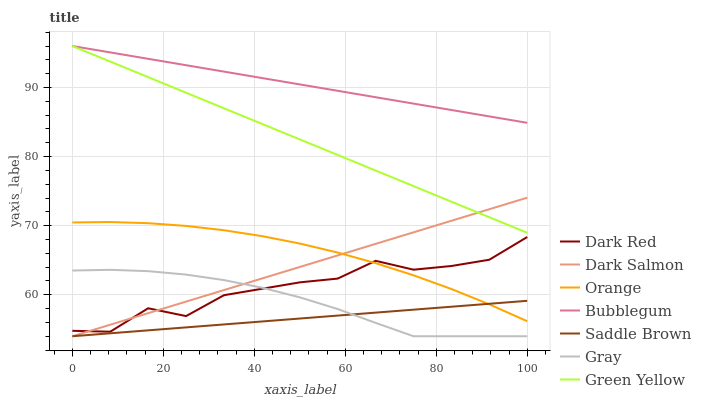Does Saddle Brown have the minimum area under the curve?
Answer yes or no. Yes. Does Bubblegum have the maximum area under the curve?
Answer yes or no. Yes. Does Dark Red have the minimum area under the curve?
Answer yes or no. No. Does Dark Red have the maximum area under the curve?
Answer yes or no. No. Is Dark Salmon the smoothest?
Answer yes or no. Yes. Is Dark Red the roughest?
Answer yes or no. Yes. Is Dark Red the smoothest?
Answer yes or no. No. Is Dark Salmon the roughest?
Answer yes or no. No. Does Gray have the lowest value?
Answer yes or no. Yes. Does Dark Red have the lowest value?
Answer yes or no. No. Does Green Yellow have the highest value?
Answer yes or no. Yes. Does Dark Red have the highest value?
Answer yes or no. No. Is Saddle Brown less than Bubblegum?
Answer yes or no. Yes. Is Bubblegum greater than Dark Salmon?
Answer yes or no. Yes. Does Saddle Brown intersect Orange?
Answer yes or no. Yes. Is Saddle Brown less than Orange?
Answer yes or no. No. Is Saddle Brown greater than Orange?
Answer yes or no. No. Does Saddle Brown intersect Bubblegum?
Answer yes or no. No. 